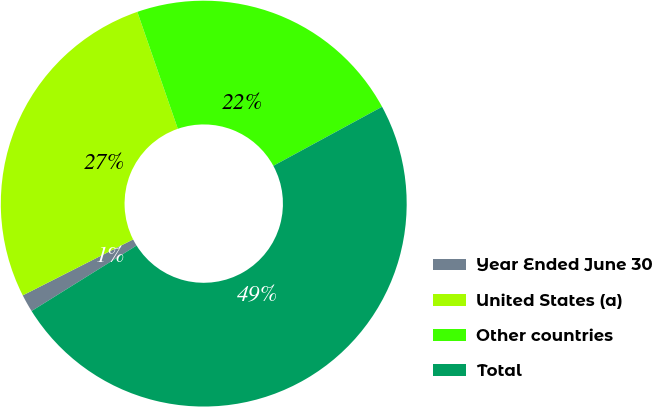<chart> <loc_0><loc_0><loc_500><loc_500><pie_chart><fcel>Year Ended June 30<fcel>United States (a)<fcel>Other countries<fcel>Total<nl><fcel>1.41%<fcel>27.16%<fcel>22.39%<fcel>49.04%<nl></chart> 